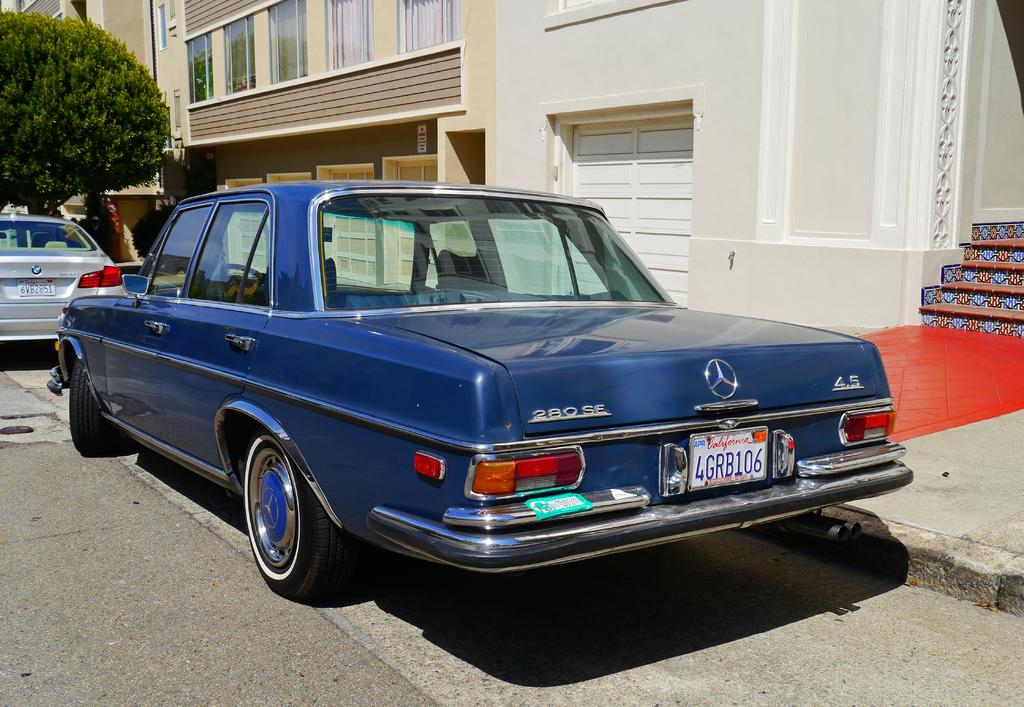What can be seen on the road in the image? There are vehicles on the road in the image. What can be seen in the distance behind the vehicles? There are buildings visible in the background of the image. Can you describe any other objects or features in the background? There are other objects present in the background of the image. What type of stick can be seen floating in space in the image? There is no stick or space present in the image; it features vehicles on a road with buildings and other objects in the background. 